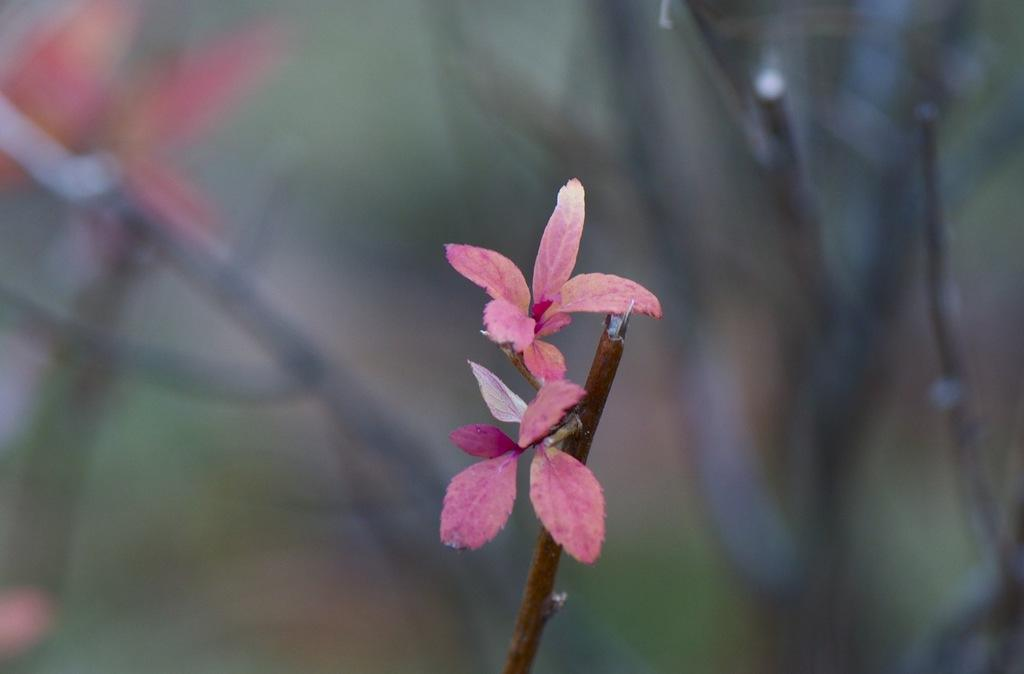What type of living organisms can be seen in the image? Plants can be seen in the image. Can you describe the background of the image? The background of the image is blurred. How many horses are visible in the image? There are no horses present in the image; it only features plants. What type of arch can be seen in the background of the image? There is no arch present in the image; the background is blurred. 